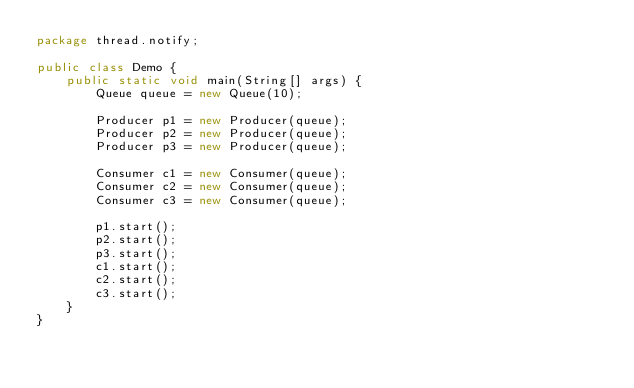<code> <loc_0><loc_0><loc_500><loc_500><_Java_>package thread.notify;

public class Demo {
    public static void main(String[] args) {
        Queue queue = new Queue(10);

        Producer p1 = new Producer(queue);
        Producer p2 = new Producer(queue);
        Producer p3 = new Producer(queue);

        Consumer c1 = new Consumer(queue);
        Consumer c2 = new Consumer(queue);
        Consumer c3 = new Consumer(queue);

        p1.start();
        p2.start();
        p3.start();
        c1.start();
        c2.start();
        c3.start();
    }
}
</code> 